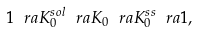Convert formula to latex. <formula><loc_0><loc_0><loc_500><loc_500>1 \ r a K _ { 0 } ^ { s o l } \ r a K _ { 0 } \ r a K _ { 0 } ^ { s s } \ r a 1 ,</formula> 